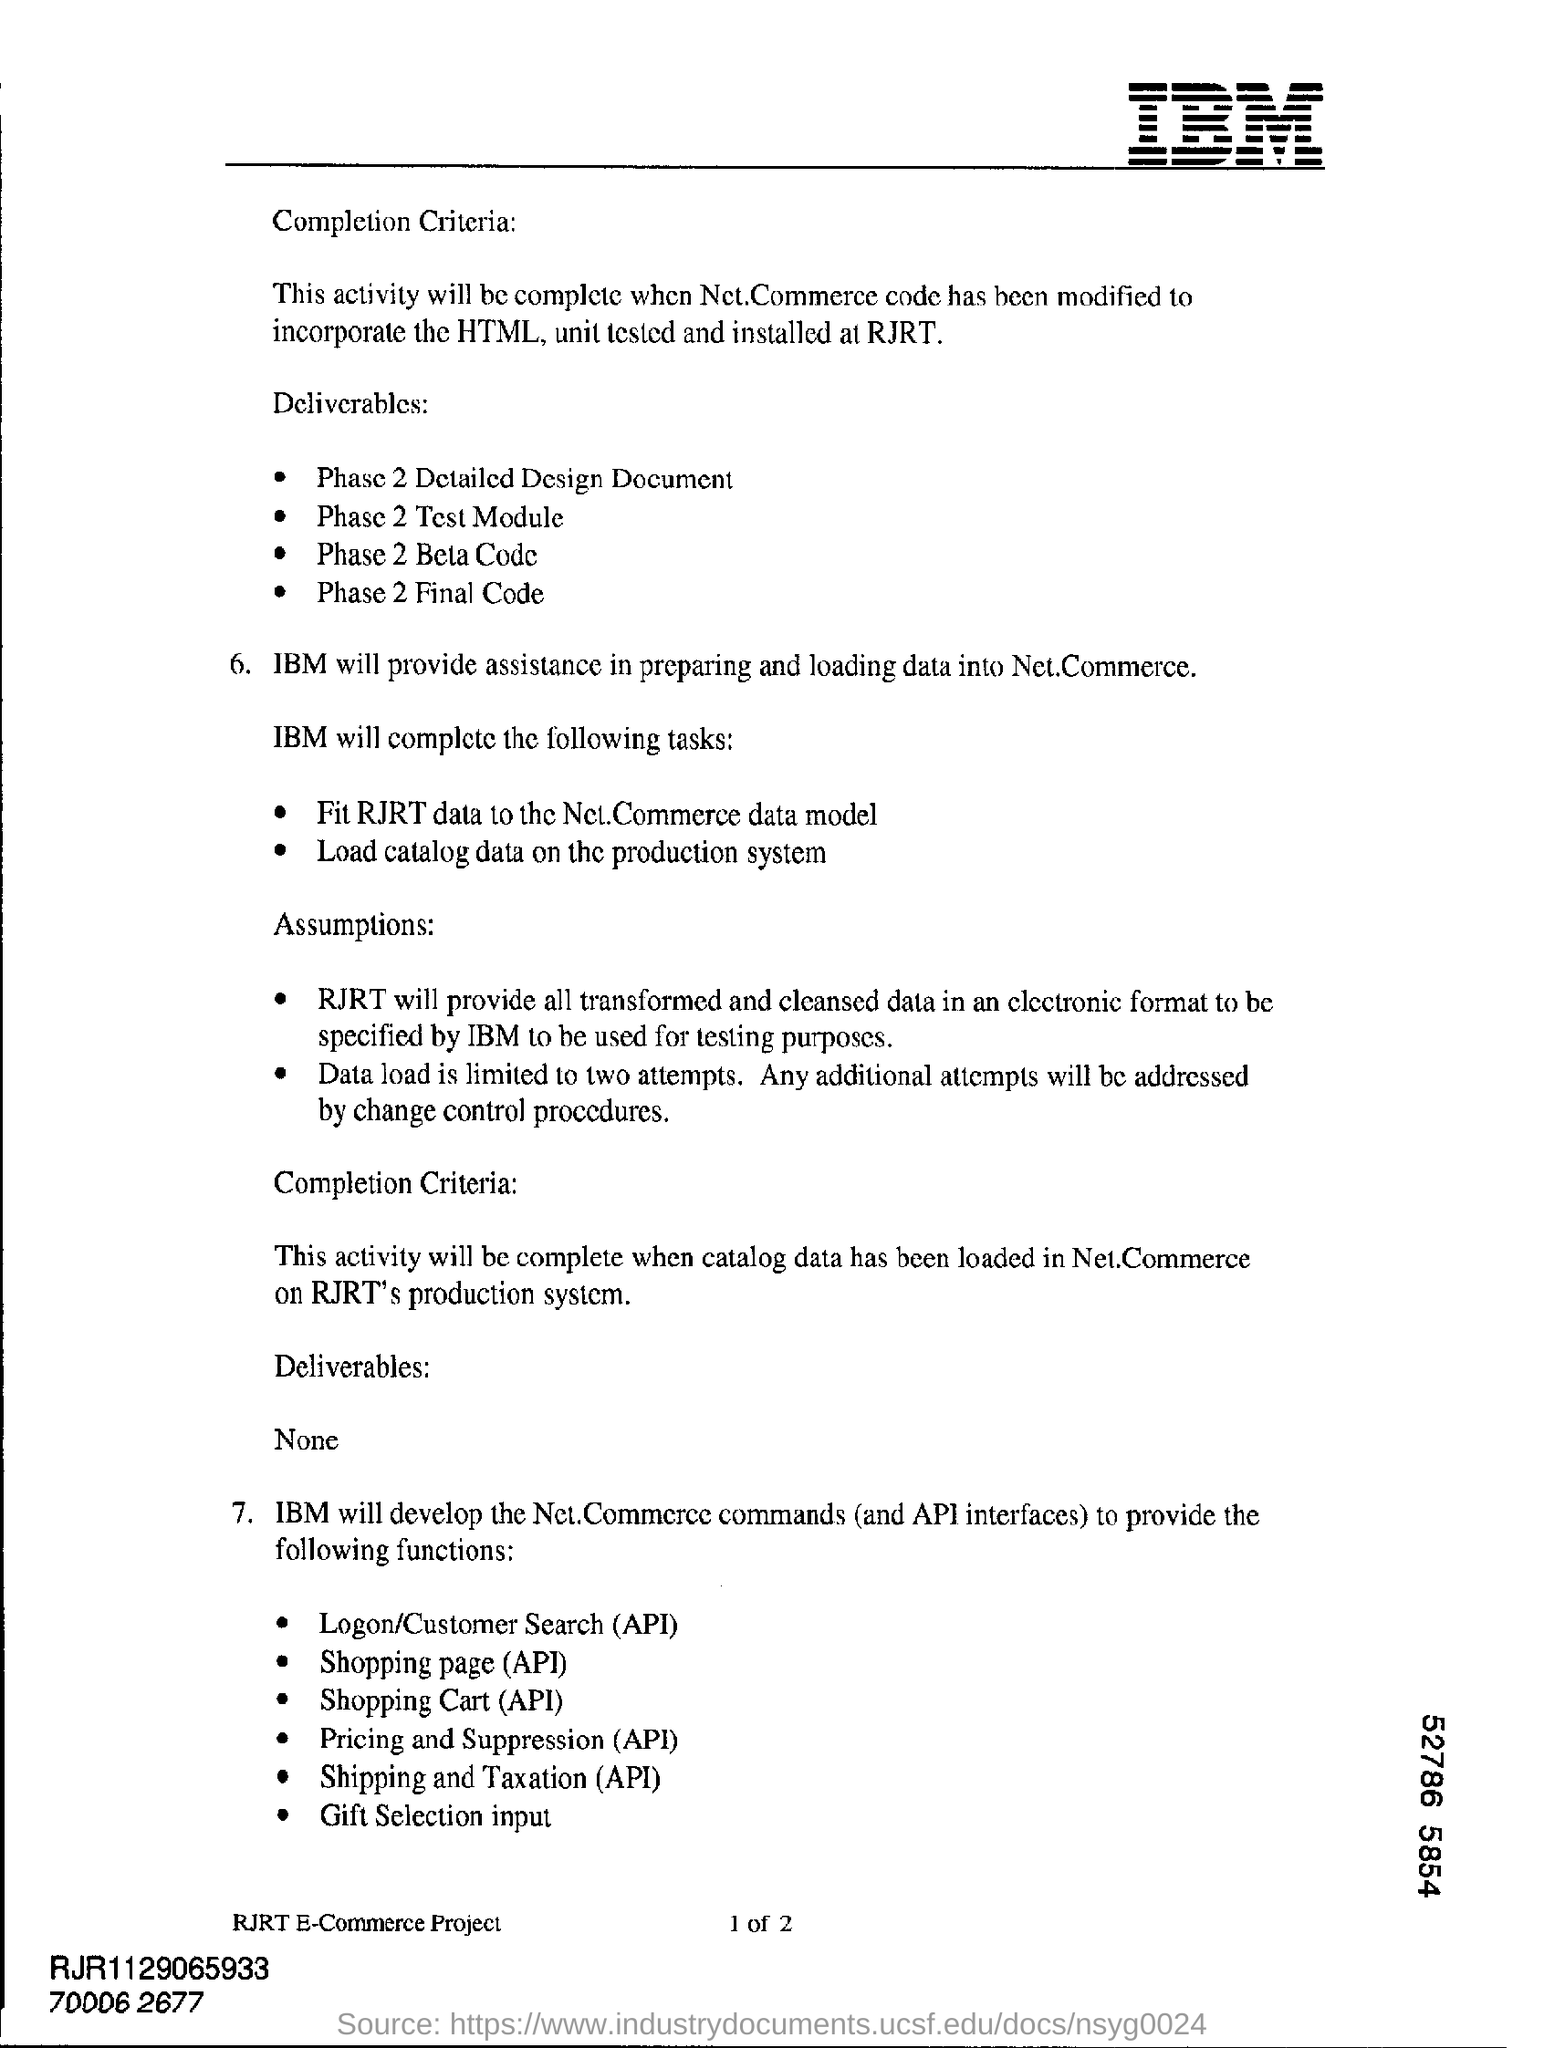What is the heading at top right of the page ?
Provide a short and direct response. Ibm. How many attempts is data load limited to?
Give a very brief answer. Two attempts. On what system the catalog data should be loaded on?
Give a very brief answer. Production. 